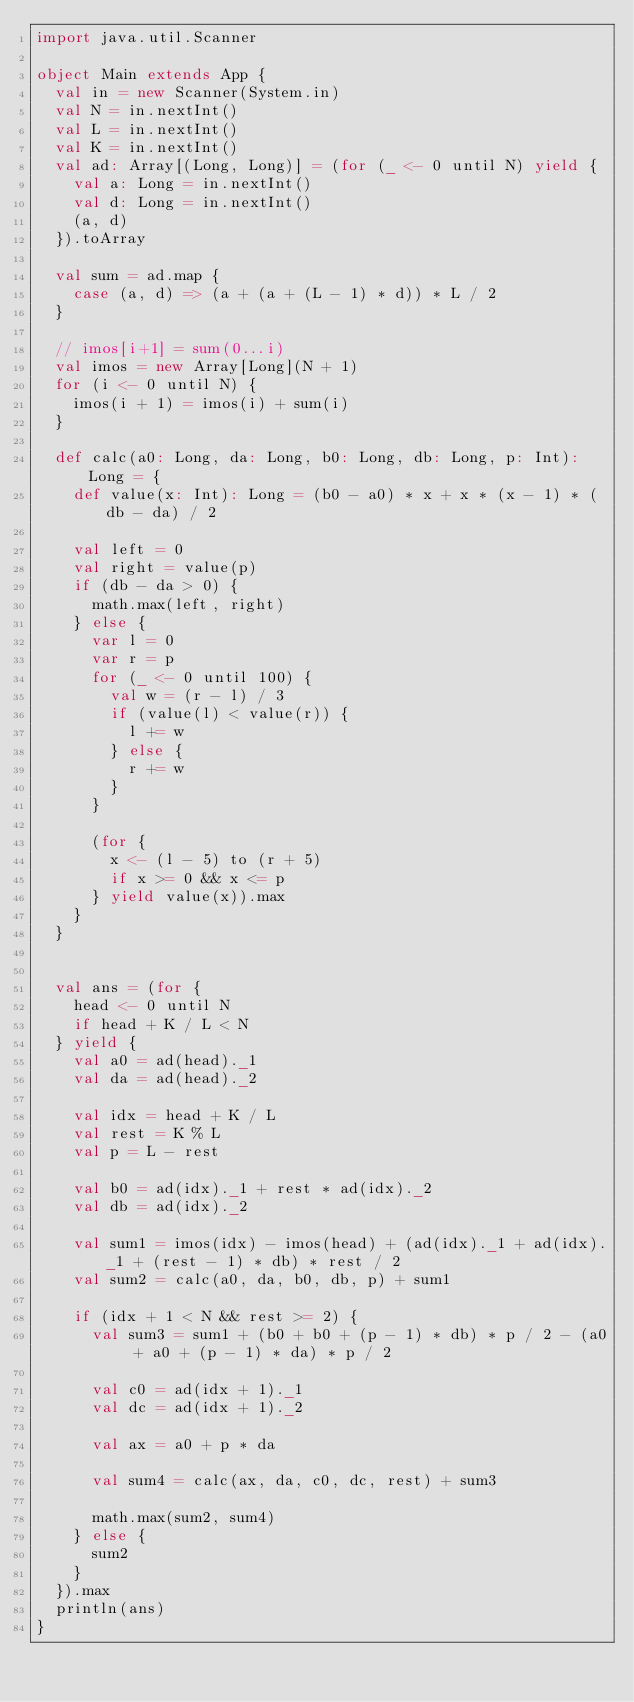<code> <loc_0><loc_0><loc_500><loc_500><_Scala_>import java.util.Scanner

object Main extends App {
  val in = new Scanner(System.in)
  val N = in.nextInt()
  val L = in.nextInt()
  val K = in.nextInt()
  val ad: Array[(Long, Long)] = (for (_ <- 0 until N) yield {
    val a: Long = in.nextInt()
    val d: Long = in.nextInt()
    (a, d)
  }).toArray

  val sum = ad.map {
    case (a, d) => (a + (a + (L - 1) * d)) * L / 2
  }

  // imos[i+1] = sum(0...i)
  val imos = new Array[Long](N + 1)
  for (i <- 0 until N) {
    imos(i + 1) = imos(i) + sum(i)
  }

  def calc(a0: Long, da: Long, b0: Long, db: Long, p: Int): Long = {
    def value(x: Int): Long = (b0 - a0) * x + x * (x - 1) * (db - da) / 2

    val left = 0
    val right = value(p)
    if (db - da > 0) {
      math.max(left, right)
    } else {
      var l = 0
      var r = p
      for (_ <- 0 until 100) {
        val w = (r - l) / 3
        if (value(l) < value(r)) {
          l += w
        } else {
          r += w
        }
      }

      (for {
        x <- (l - 5) to (r + 5)
        if x >= 0 && x <= p
      } yield value(x)).max
    }
  }


  val ans = (for {
    head <- 0 until N
    if head + K / L < N
  } yield {
    val a0 = ad(head)._1
    val da = ad(head)._2

    val idx = head + K / L
    val rest = K % L
    val p = L - rest

    val b0 = ad(idx)._1 + rest * ad(idx)._2
    val db = ad(idx)._2

    val sum1 = imos(idx) - imos(head) + (ad(idx)._1 + ad(idx)._1 + (rest - 1) * db) * rest / 2
    val sum2 = calc(a0, da, b0, db, p) + sum1

    if (idx + 1 < N && rest >= 2) {
      val sum3 = sum1 + (b0 + b0 + (p - 1) * db) * p / 2 - (a0 + a0 + (p - 1) * da) * p / 2

      val c0 = ad(idx + 1)._1
      val dc = ad(idx + 1)._2

      val ax = a0 + p * da

      val sum4 = calc(ax, da, c0, dc, rest) + sum3

      math.max(sum2, sum4)
    } else {
      sum2
    }
  }).max
  println(ans)
}</code> 